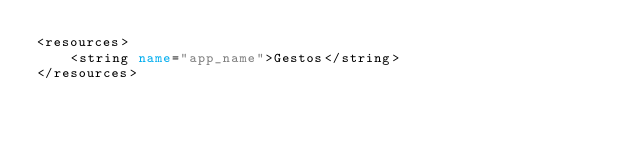Convert code to text. <code><loc_0><loc_0><loc_500><loc_500><_XML_><resources>
    <string name="app_name">Gestos</string>
</resources></code> 